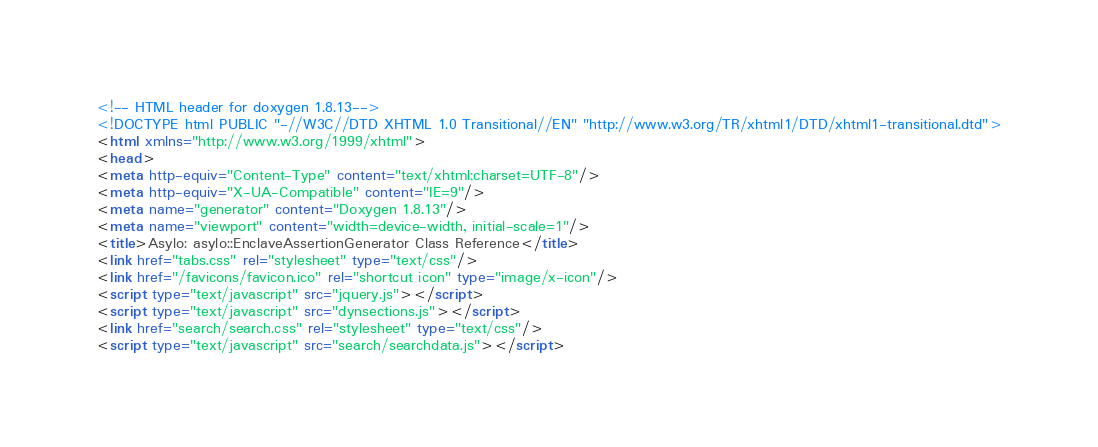Convert code to text. <code><loc_0><loc_0><loc_500><loc_500><_HTML_><!-- HTML header for doxygen 1.8.13-->
<!DOCTYPE html PUBLIC "-//W3C//DTD XHTML 1.0 Transitional//EN" "http://www.w3.org/TR/xhtml1/DTD/xhtml1-transitional.dtd">
<html xmlns="http://www.w3.org/1999/xhtml">
<head>
<meta http-equiv="Content-Type" content="text/xhtml;charset=UTF-8"/>
<meta http-equiv="X-UA-Compatible" content="IE=9"/>
<meta name="generator" content="Doxygen 1.8.13"/>
<meta name="viewport" content="width=device-width, initial-scale=1"/>
<title>Asylo: asylo::EnclaveAssertionGenerator Class Reference</title>
<link href="tabs.css" rel="stylesheet" type="text/css"/>
<link href="/favicons/favicon.ico" rel="shortcut icon" type="image/x-icon"/>
<script type="text/javascript" src="jquery.js"></script>
<script type="text/javascript" src="dynsections.js"></script>
<link href="search/search.css" rel="stylesheet" type="text/css"/>
<script type="text/javascript" src="search/searchdata.js"></script></code> 